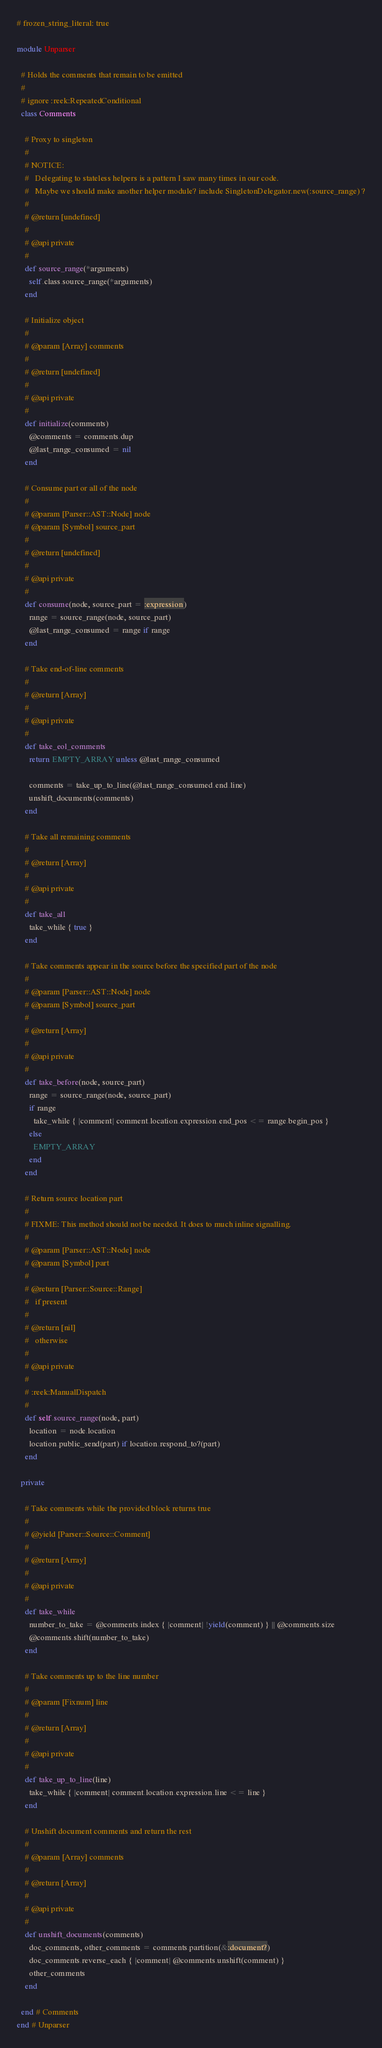Convert code to text. <code><loc_0><loc_0><loc_500><loc_500><_Ruby_># frozen_string_literal: true

module Unparser

  # Holds the comments that remain to be emitted
  #
  # ignore :reek:RepeatedConditional
  class Comments

    # Proxy to singleton
    #
    # NOTICE:
    #   Delegating to stateless helpers is a pattern I saw many times in our code.
    #   Maybe we should make another helper module? include SingletonDelegator.new(:source_range) ?
    #
    # @return [undefined]
    #
    # @api private
    #
    def source_range(*arguments)
      self.class.source_range(*arguments)
    end

    # Initialize object
    #
    # @param [Array] comments
    #
    # @return [undefined]
    #
    # @api private
    #
    def initialize(comments)
      @comments = comments.dup
      @last_range_consumed = nil
    end

    # Consume part or all of the node
    #
    # @param [Parser::AST::Node] node
    # @param [Symbol] source_part
    #
    # @return [undefined]
    #
    # @api private
    #
    def consume(node, source_part = :expression)
      range = source_range(node, source_part)
      @last_range_consumed = range if range
    end

    # Take end-of-line comments
    #
    # @return [Array]
    #
    # @api private
    #
    def take_eol_comments
      return EMPTY_ARRAY unless @last_range_consumed

      comments = take_up_to_line(@last_range_consumed.end.line)
      unshift_documents(comments)
    end

    # Take all remaining comments
    #
    # @return [Array]
    #
    # @api private
    #
    def take_all
      take_while { true }
    end

    # Take comments appear in the source before the specified part of the node
    #
    # @param [Parser::AST::Node] node
    # @param [Symbol] source_part
    #
    # @return [Array]
    #
    # @api private
    #
    def take_before(node, source_part)
      range = source_range(node, source_part)
      if range
        take_while { |comment| comment.location.expression.end_pos <= range.begin_pos }
      else
        EMPTY_ARRAY
      end
    end

    # Return source location part
    #
    # FIXME: This method should not be needed. It does to much inline signalling.
    #
    # @param [Parser::AST::Node] node
    # @param [Symbol] part
    #
    # @return [Parser::Source::Range]
    #   if present
    #
    # @return [nil]
    #   otherwise
    #
    # @api private
    #
    # :reek:ManualDispatch
    #
    def self.source_range(node, part)
      location = node.location
      location.public_send(part) if location.respond_to?(part)
    end

  private

    # Take comments while the provided block returns true
    #
    # @yield [Parser::Source::Comment]
    #
    # @return [Array]
    #
    # @api private
    #
    def take_while
      number_to_take = @comments.index { |comment| !yield(comment) } || @comments.size
      @comments.shift(number_to_take)
    end

    # Take comments up to the line number
    #
    # @param [Fixnum] line
    #
    # @return [Array]
    #
    # @api private
    #
    def take_up_to_line(line)
      take_while { |comment| comment.location.expression.line <= line }
    end

    # Unshift document comments and return the rest
    #
    # @param [Array] comments
    #
    # @return [Array]
    #
    # @api private
    #
    def unshift_documents(comments)
      doc_comments, other_comments = comments.partition(&:document?)
      doc_comments.reverse_each { |comment| @comments.unshift(comment) }
      other_comments
    end

  end # Comments
end # Unparser
</code> 